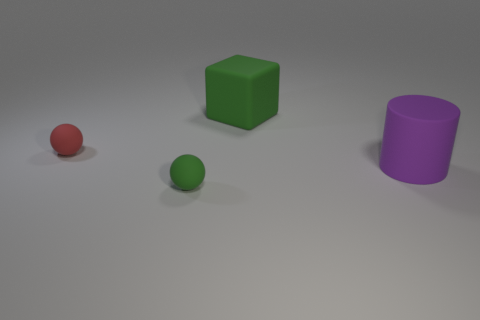Subtract all red spheres. Subtract all red cylinders. How many spheres are left? 1 Add 2 purple cylinders. How many objects exist? 6 Subtract all cubes. How many objects are left? 3 Subtract 0 green cylinders. How many objects are left? 4 Subtract all big cylinders. Subtract all tiny brown rubber spheres. How many objects are left? 3 Add 4 red rubber things. How many red rubber things are left? 5 Add 3 purple matte objects. How many purple matte objects exist? 4 